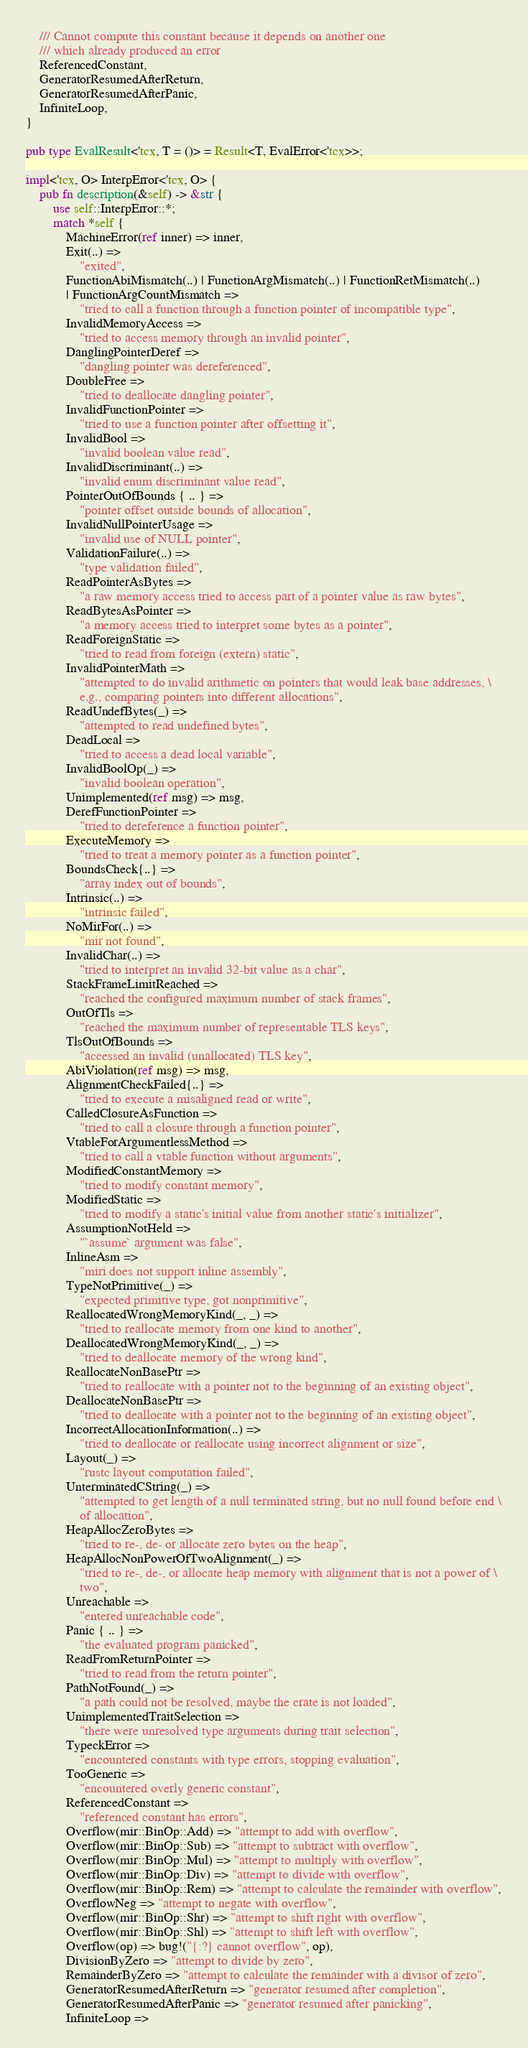<code> <loc_0><loc_0><loc_500><loc_500><_Rust_>    /// Cannot compute this constant because it depends on another one
    /// which already produced an error
    ReferencedConstant,
    GeneratorResumedAfterReturn,
    GeneratorResumedAfterPanic,
    InfiniteLoop,
}

pub type EvalResult<'tcx, T = ()> = Result<T, EvalError<'tcx>>;

impl<'tcx, O> InterpError<'tcx, O> {
    pub fn description(&self) -> &str {
        use self::InterpError::*;
        match *self {
            MachineError(ref inner) => inner,
            Exit(..) =>
                "exited",
            FunctionAbiMismatch(..) | FunctionArgMismatch(..) | FunctionRetMismatch(..)
            | FunctionArgCountMismatch =>
                "tried to call a function through a function pointer of incompatible type",
            InvalidMemoryAccess =>
                "tried to access memory through an invalid pointer",
            DanglingPointerDeref =>
                "dangling pointer was dereferenced",
            DoubleFree =>
                "tried to deallocate dangling pointer",
            InvalidFunctionPointer =>
                "tried to use a function pointer after offsetting it",
            InvalidBool =>
                "invalid boolean value read",
            InvalidDiscriminant(..) =>
                "invalid enum discriminant value read",
            PointerOutOfBounds { .. } =>
                "pointer offset outside bounds of allocation",
            InvalidNullPointerUsage =>
                "invalid use of NULL pointer",
            ValidationFailure(..) =>
                "type validation failed",
            ReadPointerAsBytes =>
                "a raw memory access tried to access part of a pointer value as raw bytes",
            ReadBytesAsPointer =>
                "a memory access tried to interpret some bytes as a pointer",
            ReadForeignStatic =>
                "tried to read from foreign (extern) static",
            InvalidPointerMath =>
                "attempted to do invalid arithmetic on pointers that would leak base addresses, \
                e.g., comparing pointers into different allocations",
            ReadUndefBytes(_) =>
                "attempted to read undefined bytes",
            DeadLocal =>
                "tried to access a dead local variable",
            InvalidBoolOp(_) =>
                "invalid boolean operation",
            Unimplemented(ref msg) => msg,
            DerefFunctionPointer =>
                "tried to dereference a function pointer",
            ExecuteMemory =>
                "tried to treat a memory pointer as a function pointer",
            BoundsCheck{..} =>
                "array index out of bounds",
            Intrinsic(..) =>
                "intrinsic failed",
            NoMirFor(..) =>
                "mir not found",
            InvalidChar(..) =>
                "tried to interpret an invalid 32-bit value as a char",
            StackFrameLimitReached =>
                "reached the configured maximum number of stack frames",
            OutOfTls =>
                "reached the maximum number of representable TLS keys",
            TlsOutOfBounds =>
                "accessed an invalid (unallocated) TLS key",
            AbiViolation(ref msg) => msg,
            AlignmentCheckFailed{..} =>
                "tried to execute a misaligned read or write",
            CalledClosureAsFunction =>
                "tried to call a closure through a function pointer",
            VtableForArgumentlessMethod =>
                "tried to call a vtable function without arguments",
            ModifiedConstantMemory =>
                "tried to modify constant memory",
            ModifiedStatic =>
                "tried to modify a static's initial value from another static's initializer",
            AssumptionNotHeld =>
                "`assume` argument was false",
            InlineAsm =>
                "miri does not support inline assembly",
            TypeNotPrimitive(_) =>
                "expected primitive type, got nonprimitive",
            ReallocatedWrongMemoryKind(_, _) =>
                "tried to reallocate memory from one kind to another",
            DeallocatedWrongMemoryKind(_, _) =>
                "tried to deallocate memory of the wrong kind",
            ReallocateNonBasePtr =>
                "tried to reallocate with a pointer not to the beginning of an existing object",
            DeallocateNonBasePtr =>
                "tried to deallocate with a pointer not to the beginning of an existing object",
            IncorrectAllocationInformation(..) =>
                "tried to deallocate or reallocate using incorrect alignment or size",
            Layout(_) =>
                "rustc layout computation failed",
            UnterminatedCString(_) =>
                "attempted to get length of a null terminated string, but no null found before end \
                of allocation",
            HeapAllocZeroBytes =>
                "tried to re-, de- or allocate zero bytes on the heap",
            HeapAllocNonPowerOfTwoAlignment(_) =>
                "tried to re-, de-, or allocate heap memory with alignment that is not a power of \
                two",
            Unreachable =>
                "entered unreachable code",
            Panic { .. } =>
                "the evaluated program panicked",
            ReadFromReturnPointer =>
                "tried to read from the return pointer",
            PathNotFound(_) =>
                "a path could not be resolved, maybe the crate is not loaded",
            UnimplementedTraitSelection =>
                "there were unresolved type arguments during trait selection",
            TypeckError =>
                "encountered constants with type errors, stopping evaluation",
            TooGeneric =>
                "encountered overly generic constant",
            ReferencedConstant =>
                "referenced constant has errors",
            Overflow(mir::BinOp::Add) => "attempt to add with overflow",
            Overflow(mir::BinOp::Sub) => "attempt to subtract with overflow",
            Overflow(mir::BinOp::Mul) => "attempt to multiply with overflow",
            Overflow(mir::BinOp::Div) => "attempt to divide with overflow",
            Overflow(mir::BinOp::Rem) => "attempt to calculate the remainder with overflow",
            OverflowNeg => "attempt to negate with overflow",
            Overflow(mir::BinOp::Shr) => "attempt to shift right with overflow",
            Overflow(mir::BinOp::Shl) => "attempt to shift left with overflow",
            Overflow(op) => bug!("{:?} cannot overflow", op),
            DivisionByZero => "attempt to divide by zero",
            RemainderByZero => "attempt to calculate the remainder with a divisor of zero",
            GeneratorResumedAfterReturn => "generator resumed after completion",
            GeneratorResumedAfterPanic => "generator resumed after panicking",
            InfiniteLoop =></code> 